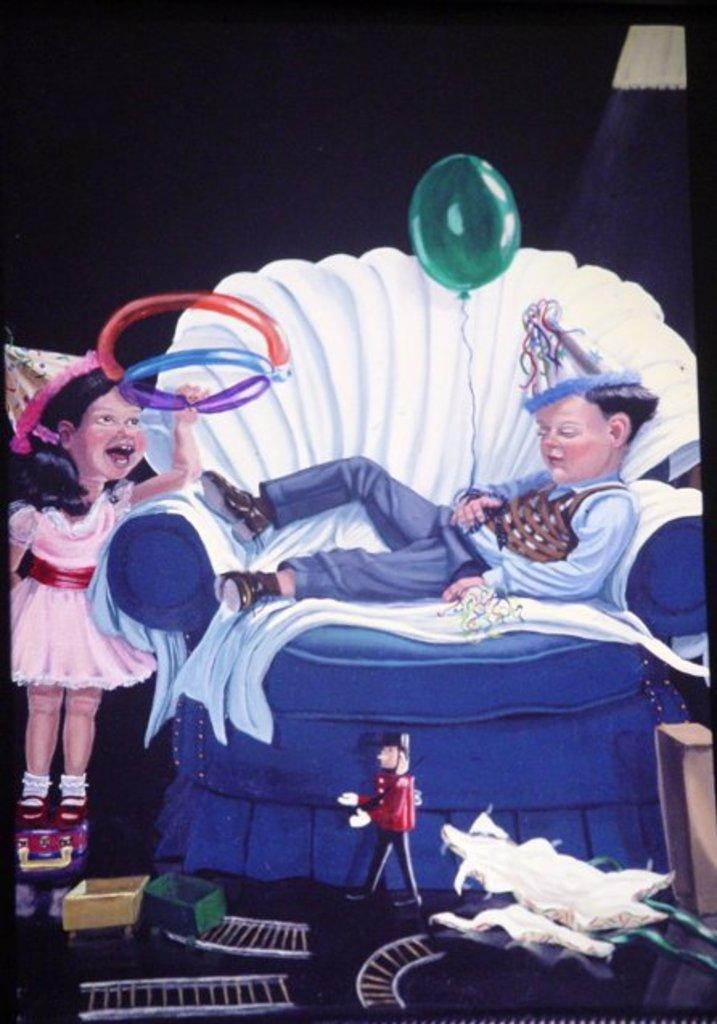What type of characters are depicted in the image? There is a cartoon picture of a boy and a girl in the image. What is the boy doing in the image? The boy is lying on a sofa in the image. What object is the boy holding in the image? The boy is holding a balloon in the image. What type of boats can be seen in the background of the image? There are no boats present in the image; it features a cartoon picture of a boy lying on a sofa and holding a balloon, along with a cartoon picture of a girl. 